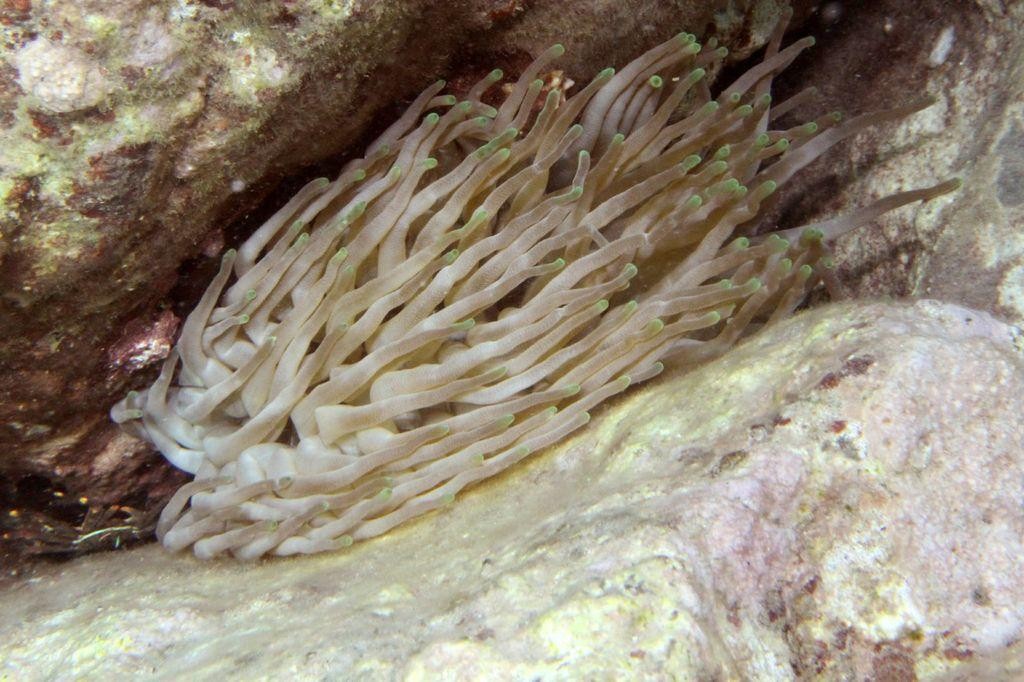What type of plant is visible in the image? There is an aquatic plant in the image. What can be seen in the background of the image? There are rocks in the background of the image. What type of music is playing in the background of the image? There is no music present in the image; it only features an aquatic plant and rocks in the background. How many lizards can be seen in the image? There are no lizards present in the image. 